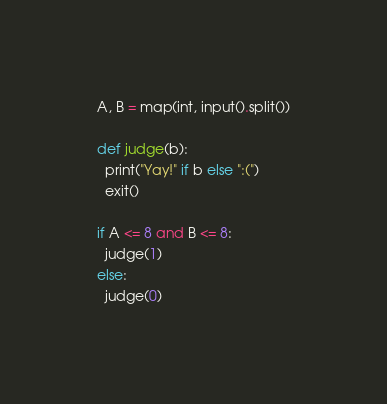<code> <loc_0><loc_0><loc_500><loc_500><_Python_>A, B = map(int, input().split())

def judge(b):
  print("Yay!" if b else ":(")
  exit()

if A <= 8 and B <= 8:
  judge(1)
else:
  judge(0)</code> 